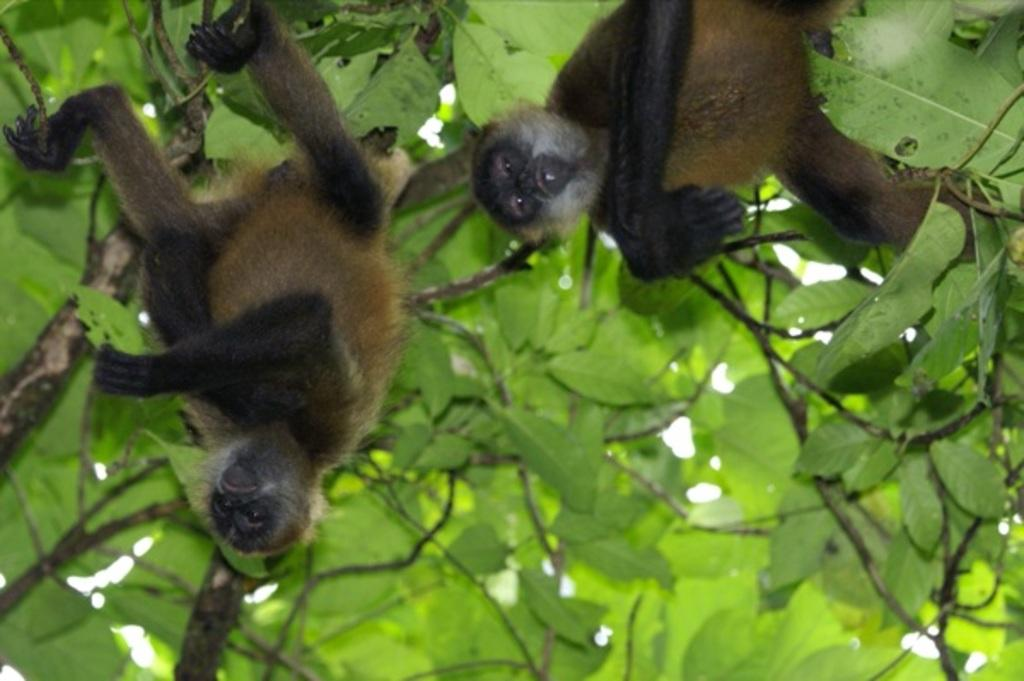How many spider monkeys are in the image? There are two spider monkeys in the image. What are the spider monkeys doing in the image? The spider monkeys are climbing trees in the image. What type of vegetation can be seen in the image? There are trees visible in the image. What is the color of the trees in the image? The trees are green in color. Where might this image have been taken? The image might have been taken in a zoo. What type of fruit is being served by the secretary in the image? There is no secretary or fruit present in the image; it features two spider monkeys climbing trees. 